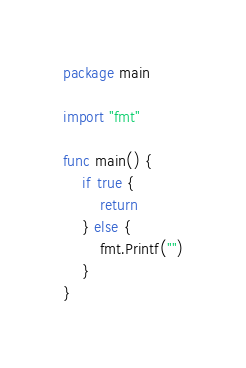<code> <loc_0><loc_0><loc_500><loc_500><_Go_>package main

import "fmt"

func main() {
	if true {
		return
	} else {
		fmt.Printf("")
	}
}
</code> 